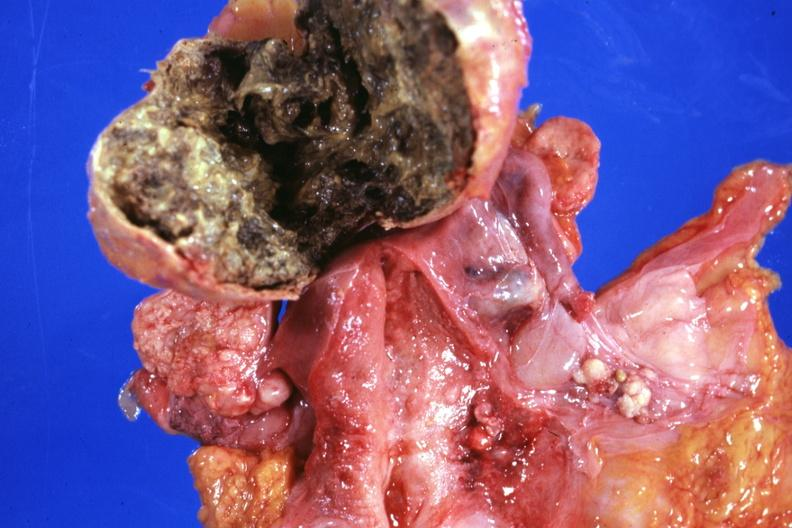does this image show opened lesion with necrotic center not too typical?
Answer the question using a single word or phrase. Yes 